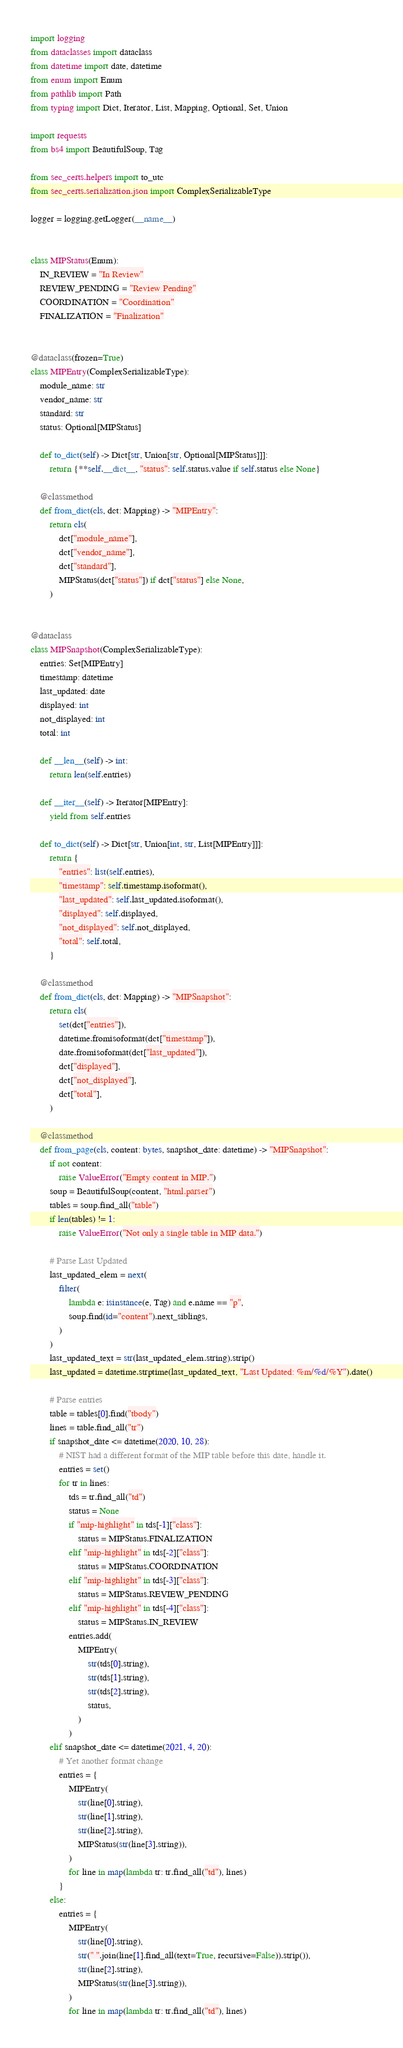<code> <loc_0><loc_0><loc_500><loc_500><_Python_>import logging
from dataclasses import dataclass
from datetime import date, datetime
from enum import Enum
from pathlib import Path
from typing import Dict, Iterator, List, Mapping, Optional, Set, Union

import requests
from bs4 import BeautifulSoup, Tag

from sec_certs.helpers import to_utc
from sec_certs.serialization.json import ComplexSerializableType

logger = logging.getLogger(__name__)


class MIPStatus(Enum):
    IN_REVIEW = "In Review"
    REVIEW_PENDING = "Review Pending"
    COORDINATION = "Coordination"
    FINALIZATION = "Finalization"


@dataclass(frozen=True)
class MIPEntry(ComplexSerializableType):
    module_name: str
    vendor_name: str
    standard: str
    status: Optional[MIPStatus]

    def to_dict(self) -> Dict[str, Union[str, Optional[MIPStatus]]]:
        return {**self.__dict__, "status": self.status.value if self.status else None}

    @classmethod
    def from_dict(cls, dct: Mapping) -> "MIPEntry":
        return cls(
            dct["module_name"],
            dct["vendor_name"],
            dct["standard"],
            MIPStatus(dct["status"]) if dct["status"] else None,
        )


@dataclass
class MIPSnapshot(ComplexSerializableType):
    entries: Set[MIPEntry]
    timestamp: datetime
    last_updated: date
    displayed: int
    not_displayed: int
    total: int

    def __len__(self) -> int:
        return len(self.entries)

    def __iter__(self) -> Iterator[MIPEntry]:
        yield from self.entries

    def to_dict(self) -> Dict[str, Union[int, str, List[MIPEntry]]]:
        return {
            "entries": list(self.entries),
            "timestamp": self.timestamp.isoformat(),
            "last_updated": self.last_updated.isoformat(),
            "displayed": self.displayed,
            "not_displayed": self.not_displayed,
            "total": self.total,
        }

    @classmethod
    def from_dict(cls, dct: Mapping) -> "MIPSnapshot":
        return cls(
            set(dct["entries"]),
            datetime.fromisoformat(dct["timestamp"]),
            date.fromisoformat(dct["last_updated"]),
            dct["displayed"],
            dct["not_displayed"],
            dct["total"],
        )

    @classmethod
    def from_page(cls, content: bytes, snapshot_date: datetime) -> "MIPSnapshot":
        if not content:
            raise ValueError("Empty content in MIP.")
        soup = BeautifulSoup(content, "html.parser")
        tables = soup.find_all("table")
        if len(tables) != 1:
            raise ValueError("Not only a single table in MIP data.")

        # Parse Last Updated
        last_updated_elem = next(
            filter(
                lambda e: isinstance(e, Tag) and e.name == "p",
                soup.find(id="content").next_siblings,
            )
        )
        last_updated_text = str(last_updated_elem.string).strip()
        last_updated = datetime.strptime(last_updated_text, "Last Updated: %m/%d/%Y").date()

        # Parse entries
        table = tables[0].find("tbody")
        lines = table.find_all("tr")
        if snapshot_date <= datetime(2020, 10, 28):
            # NIST had a different format of the MIP table before this date, handle it.
            entries = set()
            for tr in lines:
                tds = tr.find_all("td")
                status = None
                if "mip-highlight" in tds[-1]["class"]:
                    status = MIPStatus.FINALIZATION
                elif "mip-highlight" in tds[-2]["class"]:
                    status = MIPStatus.COORDINATION
                elif "mip-highlight" in tds[-3]["class"]:
                    status = MIPStatus.REVIEW_PENDING
                elif "mip-highlight" in tds[-4]["class"]:
                    status = MIPStatus.IN_REVIEW
                entries.add(
                    MIPEntry(
                        str(tds[0].string),
                        str(tds[1].string),
                        str(tds[2].string),
                        status,
                    )
                )
        elif snapshot_date <= datetime(2021, 4, 20):
            # Yet another format change
            entries = {
                MIPEntry(
                    str(line[0].string),
                    str(line[1].string),
                    str(line[2].string),
                    MIPStatus(str(line[3].string)),
                )
                for line in map(lambda tr: tr.find_all("td"), lines)
            }
        else:
            entries = {
                MIPEntry(
                    str(line[0].string),
                    str(" ".join(line[1].find_all(text=True, recursive=False)).strip()),
                    str(line[2].string),
                    MIPStatus(str(line[3].string)),
                )
                for line in map(lambda tr: tr.find_all("td"), lines)</code> 